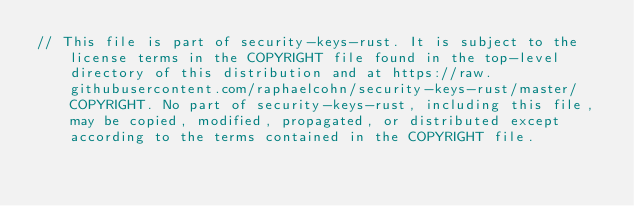Convert code to text. <code><loc_0><loc_0><loc_500><loc_500><_Rust_>// This file is part of security-keys-rust. It is subject to the license terms in the COPYRIGHT file found in the top-level directory of this distribution and at https://raw.githubusercontent.com/raphaelcohn/security-keys-rust/master/COPYRIGHT. No part of security-keys-rust, including this file, may be copied, modified, propagated, or distributed except according to the terms contained in the COPYRIGHT file.</code> 